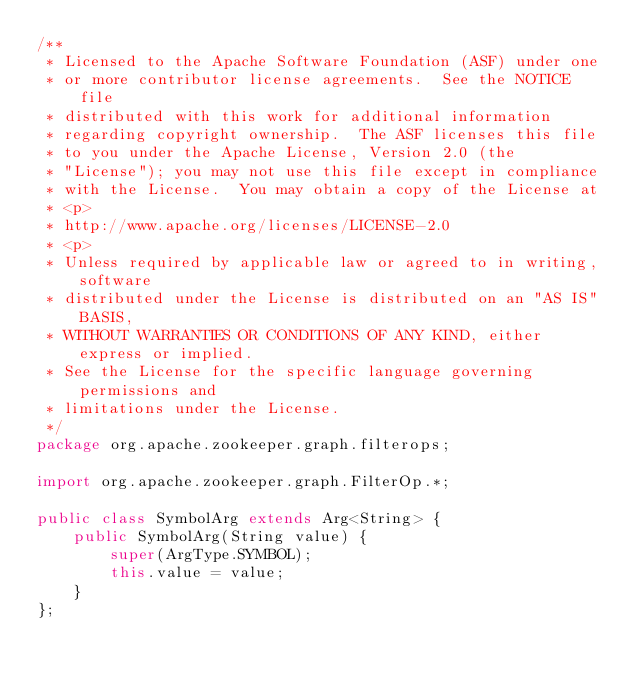Convert code to text. <code><loc_0><loc_0><loc_500><loc_500><_Java_>/**
 * Licensed to the Apache Software Foundation (ASF) under one
 * or more contributor license agreements.  See the NOTICE file
 * distributed with this work for additional information
 * regarding copyright ownership.  The ASF licenses this file
 * to you under the Apache License, Version 2.0 (the
 * "License"); you may not use this file except in compliance
 * with the License.  You may obtain a copy of the License at
 * <p>
 * http://www.apache.org/licenses/LICENSE-2.0
 * <p>
 * Unless required by applicable law or agreed to in writing, software
 * distributed under the License is distributed on an "AS IS" BASIS,
 * WITHOUT WARRANTIES OR CONDITIONS OF ANY KIND, either express or implied.
 * See the License for the specific language governing permissions and
 * limitations under the License.
 */
package org.apache.zookeeper.graph.filterops;

import org.apache.zookeeper.graph.FilterOp.*;

public class SymbolArg extends Arg<String> {
	public SymbolArg(String value) {
		super(ArgType.SYMBOL);
		this.value = value;
	}
};
</code> 